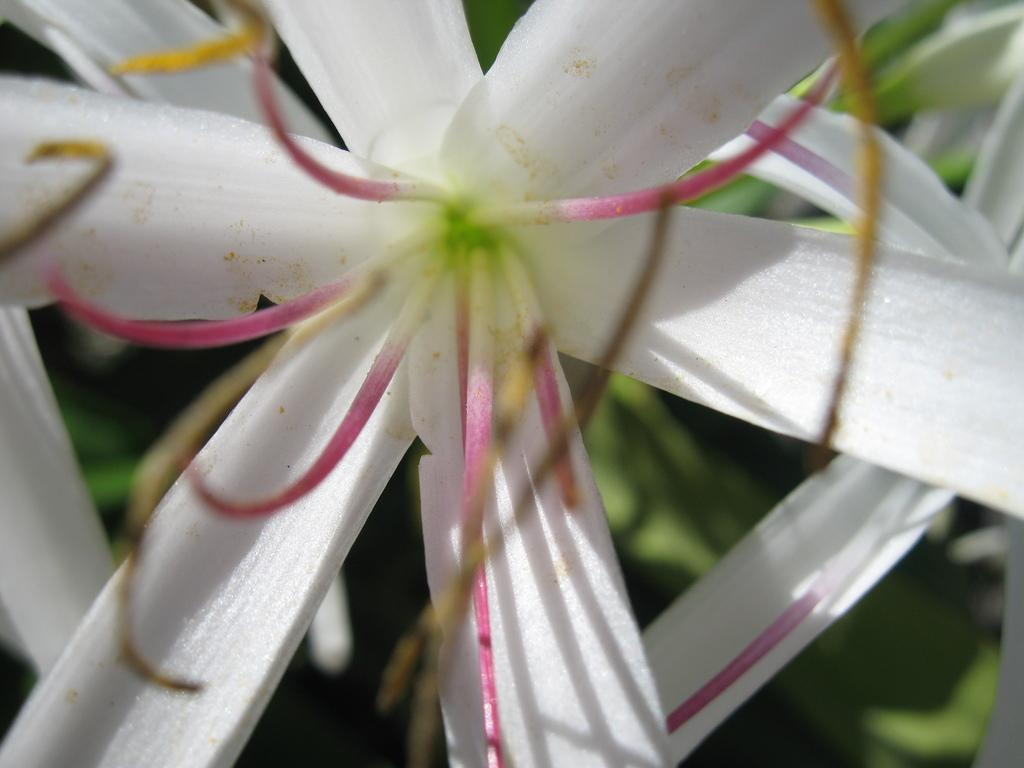Where was the image taken? The image is taken outdoors. What can be seen in the background of the image? There is a plant in the background of the image. What is the main subject of the image? There are flowers in the middle of the image. What color are the flowers? The flowers are white in color. What type of caption is written on the flowers in the image? There is no caption written on the flowers in the image. How does the coach help the flowers grow in the image? There is no coach present in the image, and therefore no assistance in growing the flowers. 